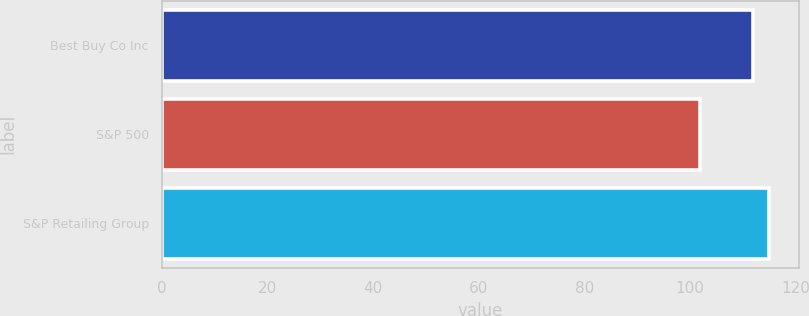Convert chart to OTSL. <chart><loc_0><loc_0><loc_500><loc_500><bar_chart><fcel>Best Buy Co Inc<fcel>S&P 500<fcel>S&P Retailing Group<nl><fcel>111.84<fcel>101.88<fcel>114.87<nl></chart> 